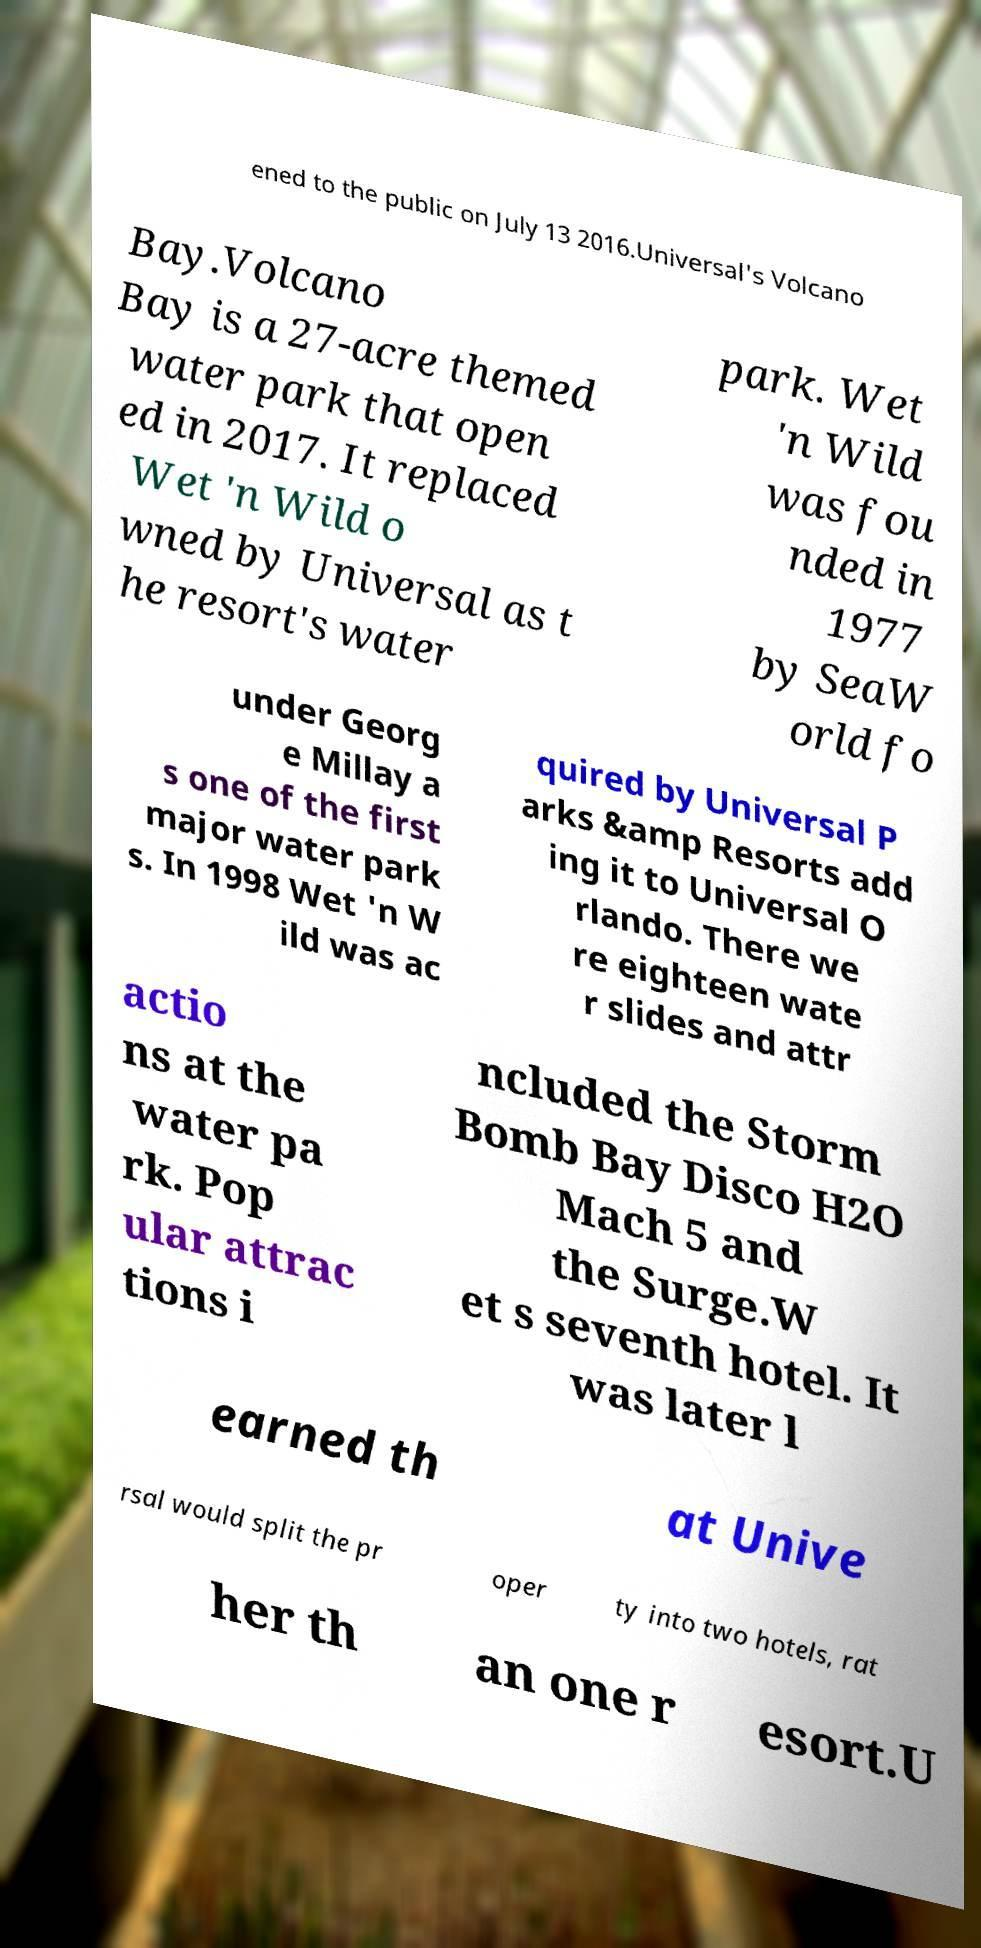Could you extract and type out the text from this image? ened to the public on July 13 2016.Universal's Volcano Bay.Volcano Bay is a 27-acre themed water park that open ed in 2017. It replaced Wet 'n Wild o wned by Universal as t he resort's water park. Wet 'n Wild was fou nded in 1977 by SeaW orld fo under Georg e Millay a s one of the first major water park s. In 1998 Wet 'n W ild was ac quired by Universal P arks &amp Resorts add ing it to Universal O rlando. There we re eighteen wate r slides and attr actio ns at the water pa rk. Pop ular attrac tions i ncluded the Storm Bomb Bay Disco H2O Mach 5 and the Surge.W et s seventh hotel. It was later l earned th at Unive rsal would split the pr oper ty into two hotels, rat her th an one r esort.U 